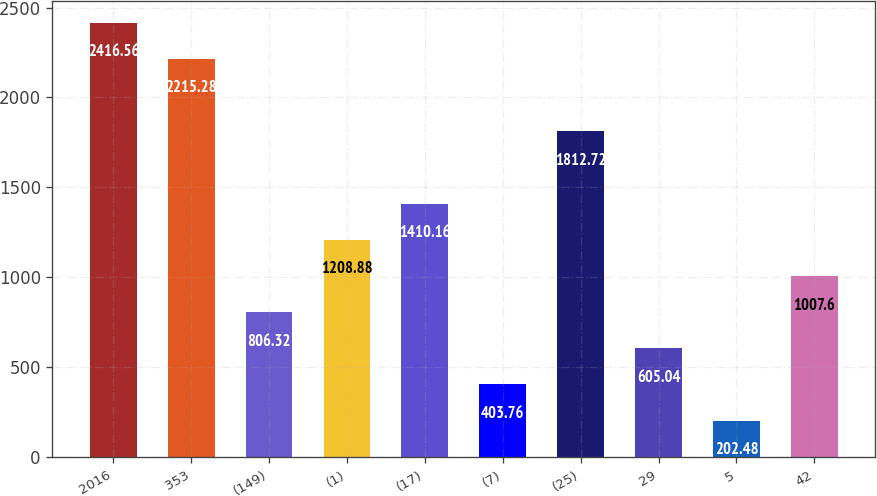Convert chart to OTSL. <chart><loc_0><loc_0><loc_500><loc_500><bar_chart><fcel>2016<fcel>353<fcel>(149)<fcel>(1)<fcel>(17)<fcel>(7)<fcel>(25)<fcel>29<fcel>5<fcel>42<nl><fcel>2416.56<fcel>2215.28<fcel>806.32<fcel>1208.88<fcel>1410.16<fcel>403.76<fcel>1812.72<fcel>605.04<fcel>202.48<fcel>1007.6<nl></chart> 